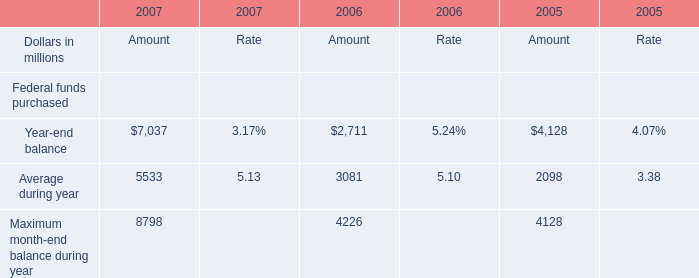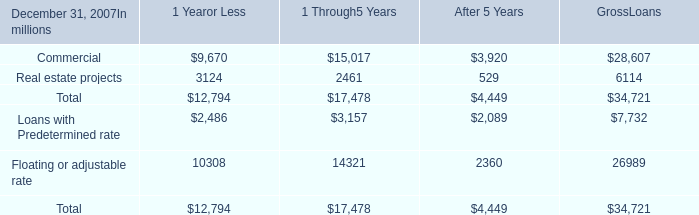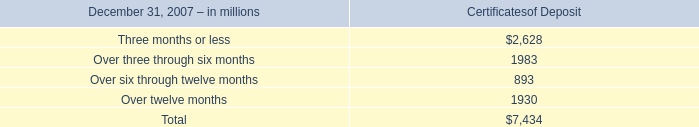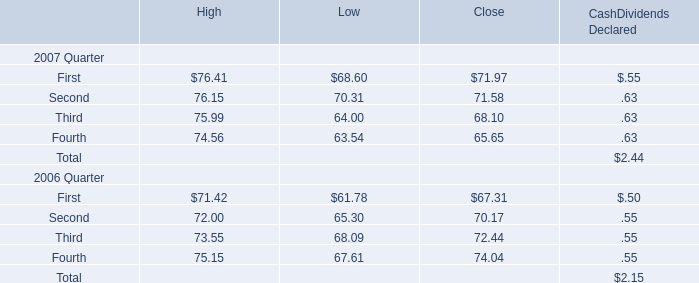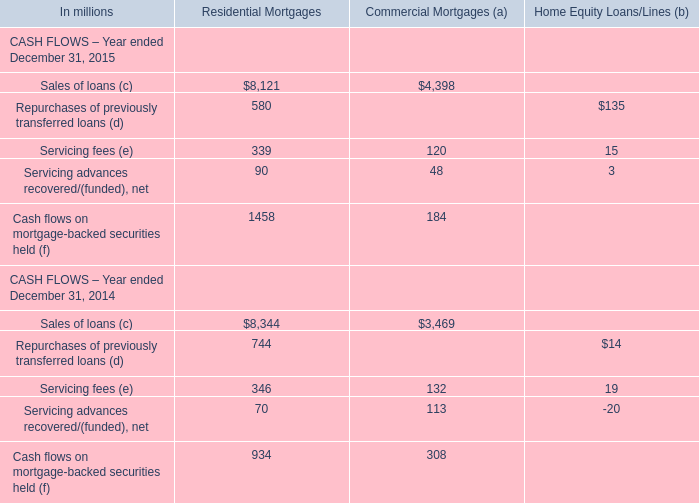What's the total amount of the Second for High in the years where First for High greater than 70? 
Computations: (76.15 + 72)
Answer: 148.15. 